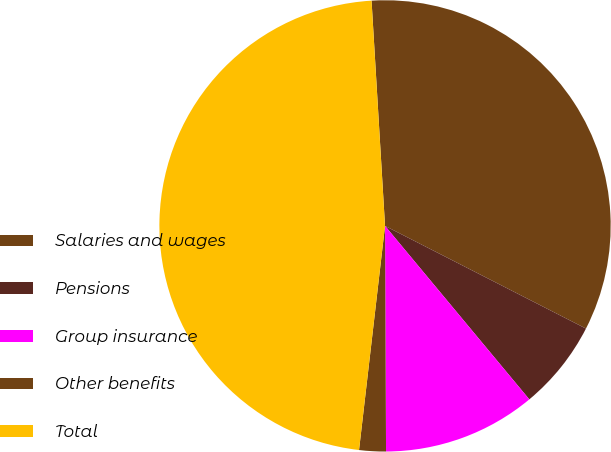<chart> <loc_0><loc_0><loc_500><loc_500><pie_chart><fcel>Salaries and wages<fcel>Pensions<fcel>Group insurance<fcel>Other benefits<fcel>Total<nl><fcel>33.47%<fcel>6.44%<fcel>10.97%<fcel>1.91%<fcel>47.21%<nl></chart> 